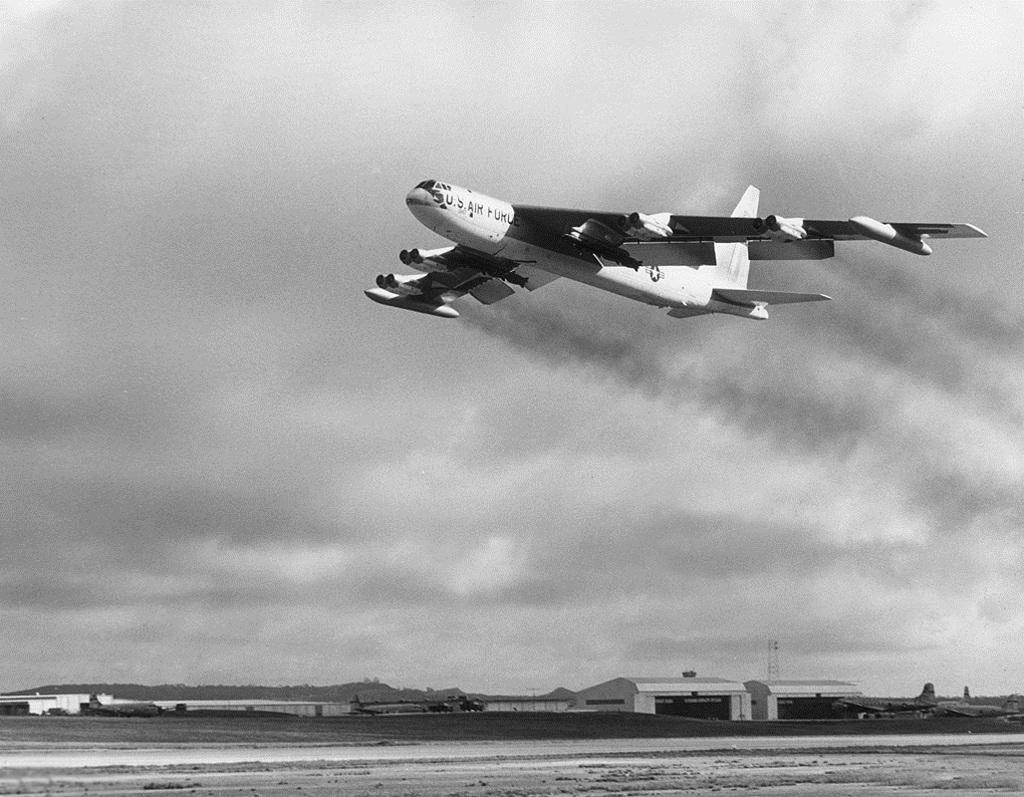<image>
Present a compact description of the photo's key features. A large US Air Force Jet is flying over an airfield. 